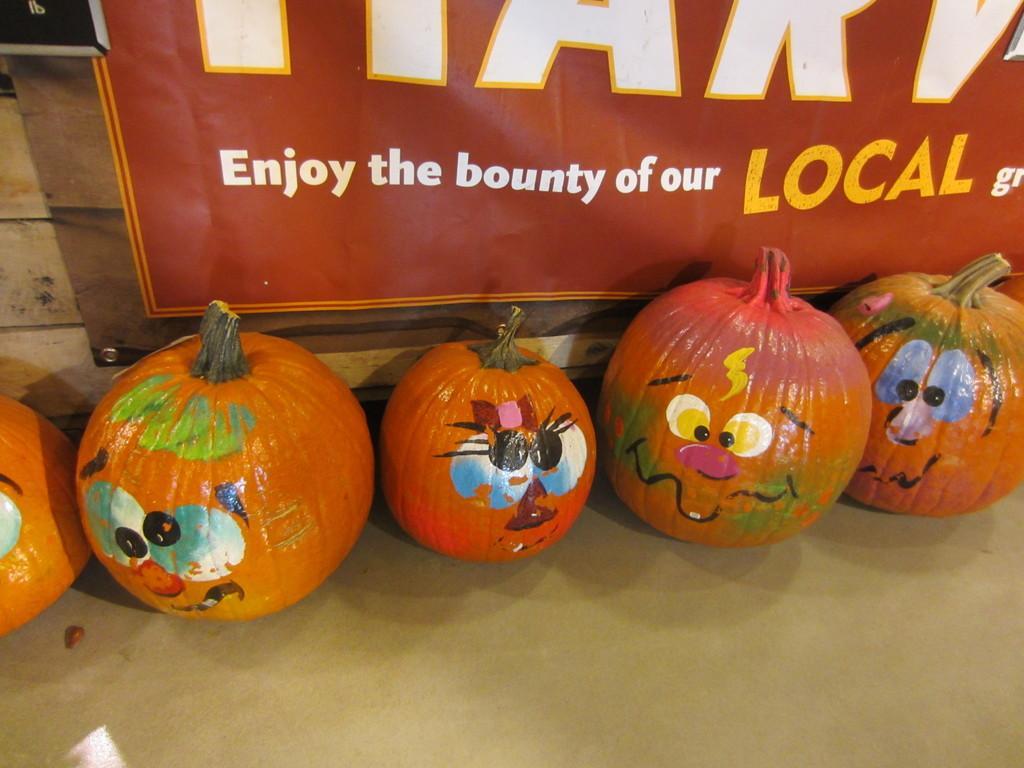How would you summarize this image in a sentence or two? In this image we can see a few pumpkins with some paintings on it and in the background we can see a board with some text. 